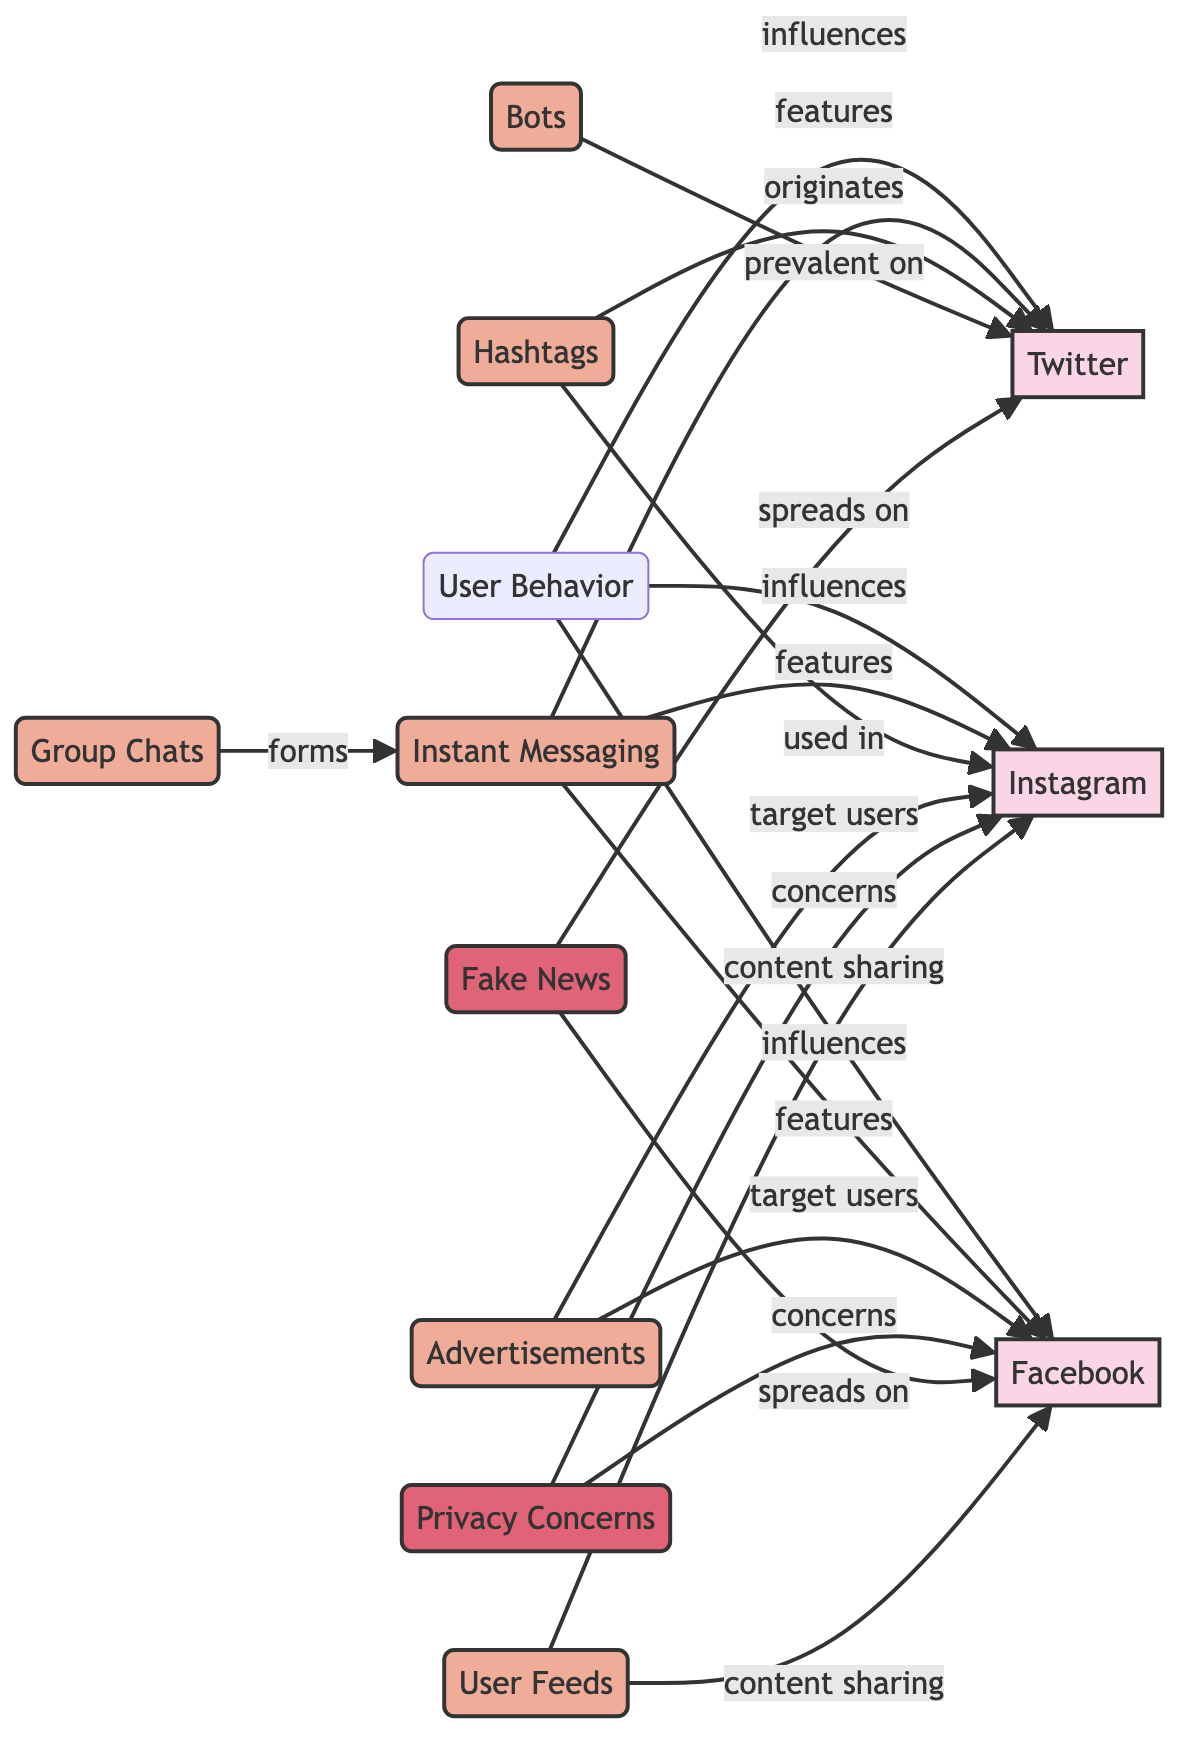What are the three social media platforms influenced by user behavior? The diagram shows user behavior influencing three nodes: Facebook, Twitter, and Instagram. Therefore, these are the three platforms that are impacted.
Answer: Facebook, Twitter, Instagram Which feature is prevalent on Twitter? The diagram specifies that bots are identified as prevalent on Twitter, with a direct edge labeled "prevalent on."
Answer: Bots How many edges are there in total that connect to the privacy concerns node? The diagram shows two edges connecting to the privacy concerns node, both indicating concerns with Facebook and Instagram.
Answer: 2 Which social media platform allows content sharing from user feeds? The diagram states that user feeds connect to both Facebook and Instagram for content sharing, indicating both platforms support this feature.
Answer: Facebook, Instagram What originates with hashtags in the diagram? The diagram defines that hashtags originate with Twitter, as indicated by the specific edge labeled "originates."
Answer: Twitter Which platform has advertisements targeting users? The diagram specifies that Facebook and Instagram are targeted by advertisements, with labeled edges indicating this relationship.
Answer: Facebook, Instagram Identify the relationship between group chats and instant messaging. The diagram shows that group chats form within instant messaging, as represented by the edge labeled "forms." This indicates that group chats are a feature of instant messaging.
Answer: Forms How many platforms are influenced by instant messaging in the diagram? The diagram shows that instant messaging has edges leading to three platforms—Facebook, Twitter, and Instagram. This indicates that three platforms are influenced by it.
Answer: 3 On which platforms does fake news spread according to the diagram? The diagram indicates that fake news spreads on Facebook and Twitter, as shown by the edges labeled "spreads on."
Answer: Facebook, Twitter 